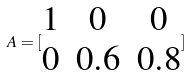Convert formula to latex. <formula><loc_0><loc_0><loc_500><loc_500>A = [ \begin{matrix} 1 & 0 & 0 \\ 0 & 0 . 6 & 0 . 8 \end{matrix} ]</formula> 